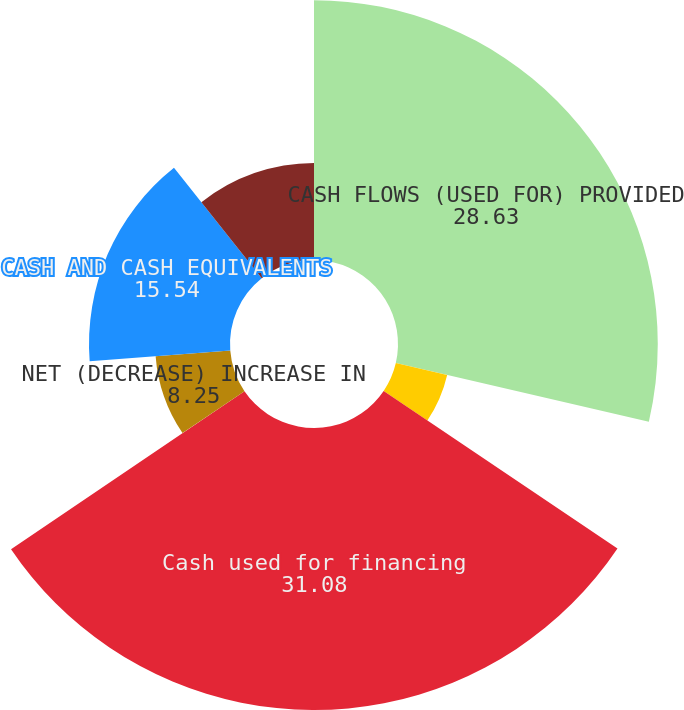<chart> <loc_0><loc_0><loc_500><loc_500><pie_chart><fcel>CASH FLOWS (USED FOR) PROVIDED<fcel>Cash used for investing<fcel>Cash used for financing<fcel>NET (DECREASE) INCREASE IN<fcel>CASH AND CASH EQUIVALENTS<fcel>CASH AND CASH EQUIVALENTS END<nl><fcel>28.63%<fcel>5.81%<fcel>31.08%<fcel>8.25%<fcel>15.54%<fcel>10.69%<nl></chart> 